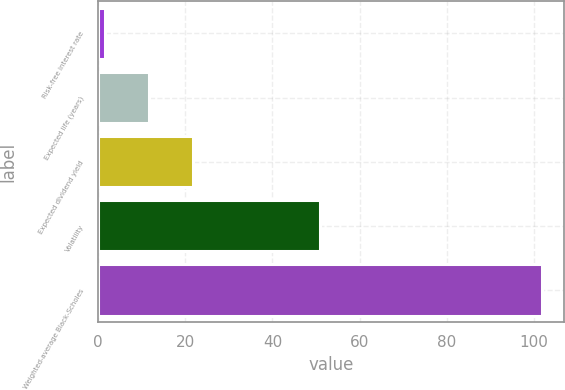Convert chart to OTSL. <chart><loc_0><loc_0><loc_500><loc_500><bar_chart><fcel>Risk-free interest rate<fcel>Expected life (years)<fcel>Expected dividend yield<fcel>Volatility<fcel>Weighted-average Black-Scholes<nl><fcel>1.6<fcel>11.63<fcel>21.66<fcel>51<fcel>101.91<nl></chart> 